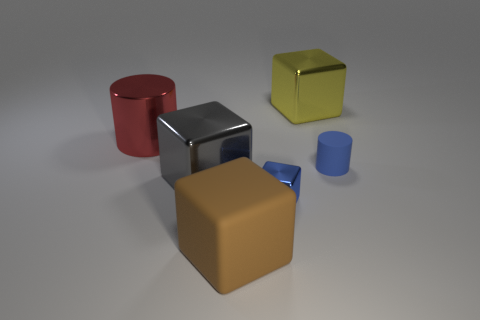Add 4 cyan matte balls. How many objects exist? 10 Subtract all cylinders. How many objects are left? 4 Subtract all big red metallic things. Subtract all large cubes. How many objects are left? 2 Add 1 big yellow shiny objects. How many big yellow shiny objects are left? 2 Add 2 big gray metallic objects. How many big gray metallic objects exist? 3 Subtract 1 blue cylinders. How many objects are left? 5 